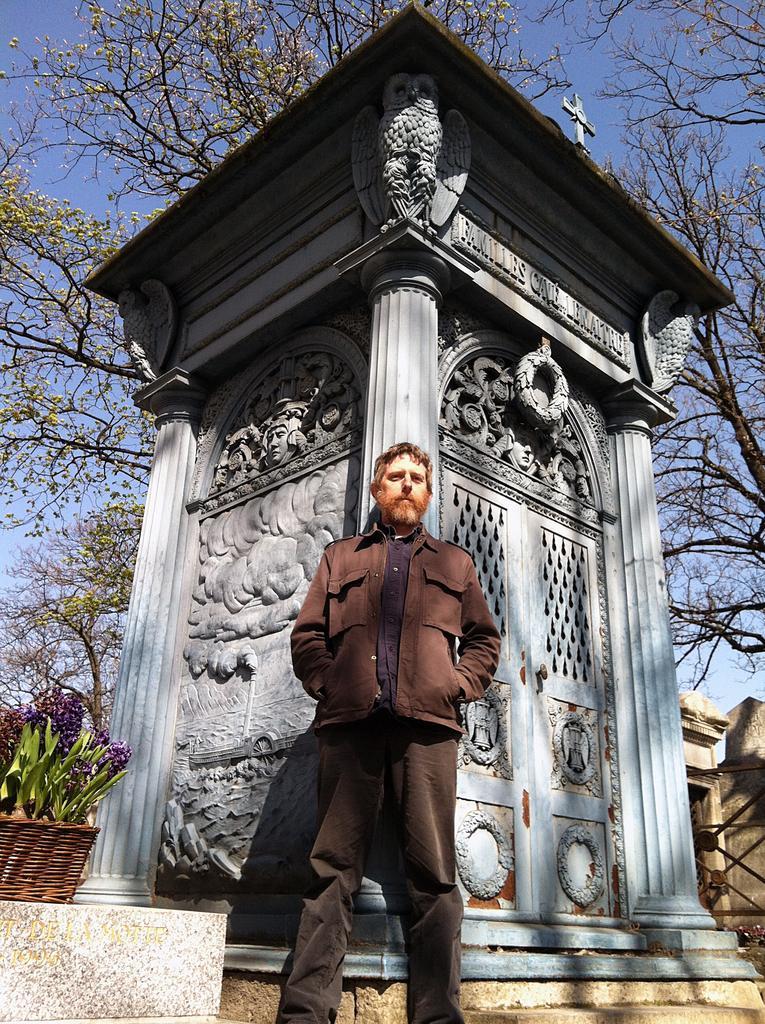How would you summarize this image in a sentence or two? In this image in front there is a person. Behind him there is a concrete structure with a cross symbol on it. Beside him there are plants. In the background of the image there are trees and sky. 